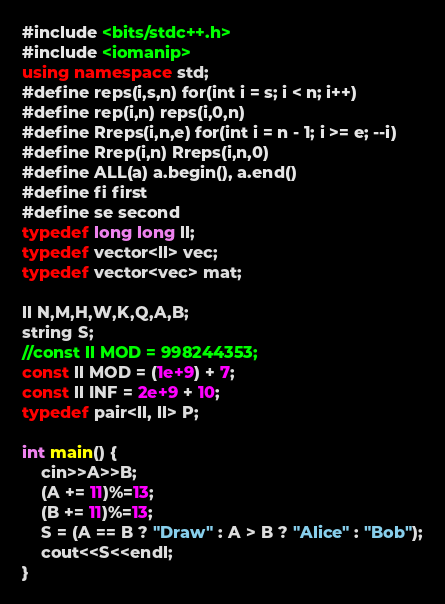<code> <loc_0><loc_0><loc_500><loc_500><_C++_>#include <bits/stdc++.h>
#include <iomanip>
using namespace std;
#define reps(i,s,n) for(int i = s; i < n; i++)
#define rep(i,n) reps(i,0,n)
#define Rreps(i,n,e) for(int i = n - 1; i >= e; --i)
#define Rrep(i,n) Rreps(i,n,0)
#define ALL(a) a.begin(), a.end()
#define fi first
#define se second
typedef long long ll;
typedef vector<ll> vec;
typedef vector<vec> mat;

ll N,M,H,W,K,Q,A,B;
string S;
//const ll MOD = 998244353;
const ll MOD = (1e+9) + 7;
const ll INF = 2e+9 + 10;
typedef pair<ll, ll> P;

int main() {
    cin>>A>>B;
    (A += 11)%=13;
    (B += 11)%=13;
    S = (A == B ? "Draw" : A > B ? "Alice" : "Bob");
    cout<<S<<endl;
}</code> 